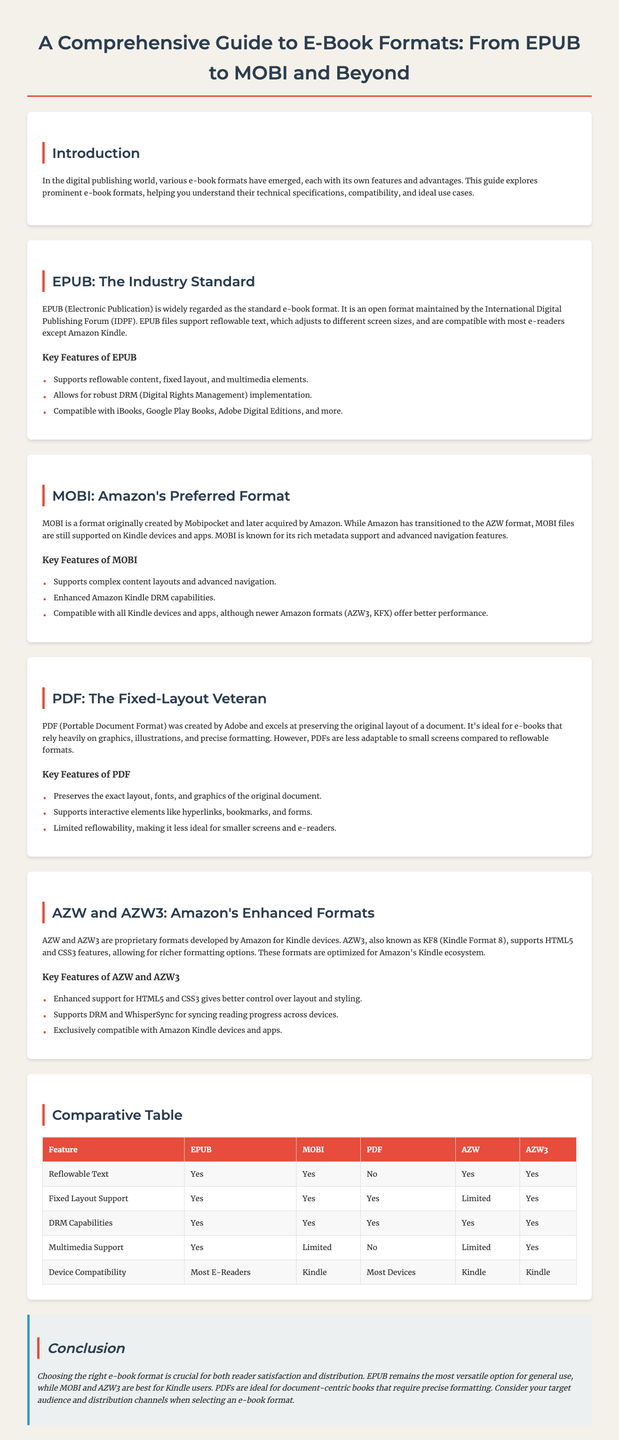What is the industry standard e-book format? The document states that EPUB is widely regarded as the standard e-book format.
Answer: EPUB Which format is known as Amazon's preferred format? The document mentions that MOBI is a format originally created by Mobipocket and later acquired by Amazon.
Answer: MOBI What is the main advantage of PDF? The guide describes that PDF excels at preserving the original layout of a document.
Answer: Preserves layout Which two features do both EPUB and AZW3 support? The document lists features such as reflowable text and DRM capabilities for both formats.
Answer: Reflowable text, DRM capabilities What are the two proprietary formats developed by Amazon? The document refers to AZW and AZW3 as proprietary formats developed by Amazon.
Answer: AZW and AZW3 How many e-book formats are detailed in the infographic? The section headings in the document indicate that there are five e-book formats discussed.
Answer: Five What type of document layout does the PDF format typically maintain? The document states that PDF preserves the exact layout, fonts, and graphics of the original document.
Answer: Fixed layout What does DRM stand for in the context of e-book formats? The document explains that DRM refers to Digital Rights Management, which is supported by most formats listed.
Answer: Digital Rights Management 